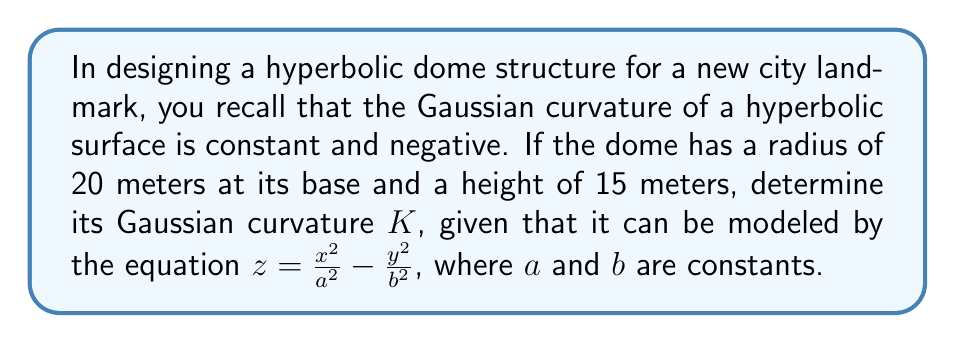Provide a solution to this math problem. To solve this problem, we'll follow these steps:

1) For a hyperbolic paraboloid of the form $z = \frac{x^2}{a^2} - \frac{y^2}{b^2}$, the Gaussian curvature K is given by:

   $$K = -\frac{4}{a^2b^2}$$

2) We need to find a and b using the given dimensions. The radius at the base (20 m) corresponds to either a or b, and the height (15 m) corresponds to the maximum z value.

3) Let's assume a = 20 (radius at base). At the highest point of the dome (x = 20, y = 0):

   $$15 = \frac{20^2}{20^2} - \frac{0^2}{b^2} = 1$$

   This doesn't match our height, so we need to scale the equation.

4) Let's introduce a scaling factor c:

   $$z = c(\frac{x^2}{a^2} - \frac{y^2}{b^2})$$

   Now, $15 = c(1) \implies c = 15$

5) Our equation becomes:

   $$z = 15(\frac{x^2}{20^2} - \frac{y^2}{b^2})$$

6) To find b, we use the fact that at the edge of the base (x = 0, y = 20), z = 0:

   $$0 = 15(\frac{0^2}{20^2} - \frac{20^2}{b^2})$$
   $$\frac{20^2}{b^2} = 0$$
   $$b = 20$$

7) Now we have a = b = 20. The Gaussian curvature is:

   $$K = -\frac{4}{a^2b^2} = -\frac{4}{20^2 \cdot 20^2} = -\frac{1}{2000} \text{ m}^{-2}$$

[asy]
import graph3;
size(200);
currentprojection=perspective(6,3,2);
triple f(pair t) {return (t.x,t.y,15*(t.x^2/400-t.y^2/400));}
surface s=surface(f,(-20,-20),(20,20),20,20,Spline);
draw(s,paleblue);
draw((-20,0,0)--(20,0,0),arrow=Arrow3);
draw((0,-20,0)--(0,20,0),arrow=Arrow3);
draw((0,0,0)--(0,0,15),arrow=Arrow3);
label("x",(-20,0,0),W);
label("y",(0,-20,0),S);
label("z",(0,0,15),N);
[/asy]
Answer: $K = -\frac{1}{2000} \text{ m}^{-2}$ 